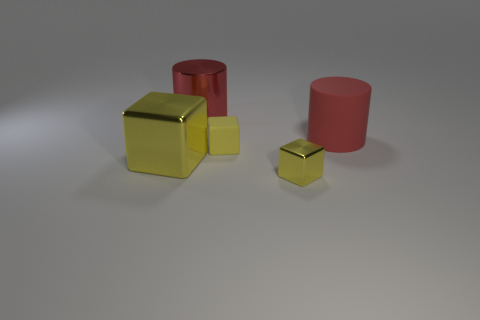There is a metal thing that is the same color as the tiny metal cube; what size is it?
Offer a very short reply. Large. The matte thing in front of the large red object on the right side of the red cylinder that is left of the tiny rubber object is what color?
Give a very brief answer. Yellow. There is another big red thing that is the same shape as the big red metal object; what is its material?
Offer a terse response. Rubber. How many rubber blocks are the same size as the red rubber object?
Your answer should be compact. 0. What number of yellow metal blocks are there?
Provide a short and direct response. 2. Is the big yellow block made of the same material as the yellow thing that is in front of the large yellow metallic thing?
Your response must be concise. Yes. How many red things are metal cylinders or small matte cylinders?
Offer a very short reply. 1. The cylinder that is the same material as the large yellow cube is what size?
Offer a very short reply. Large. How many large yellow metal objects have the same shape as the big matte object?
Provide a succinct answer. 0. Are there more large red rubber cylinders in front of the yellow rubber thing than big red metal cylinders that are in front of the big yellow cube?
Ensure brevity in your answer.  No. 